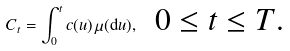Convert formula to latex. <formula><loc_0><loc_0><loc_500><loc_500>C _ { t } = \int _ { 0 } ^ { t } c ( u ) \, \mu ( { \mathrm d u } ) , \ \text {\ $0\leq t\leq T$.}</formula> 